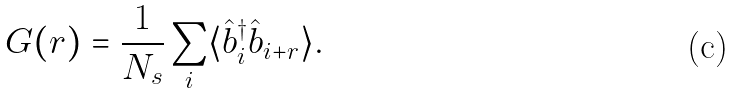Convert formula to latex. <formula><loc_0><loc_0><loc_500><loc_500>G ( r ) = \frac { 1 } { N _ { s } } \sum _ { i } \langle \hat { b } _ { i } ^ { \dagger } \hat { b } _ { i + r } \rangle .</formula> 